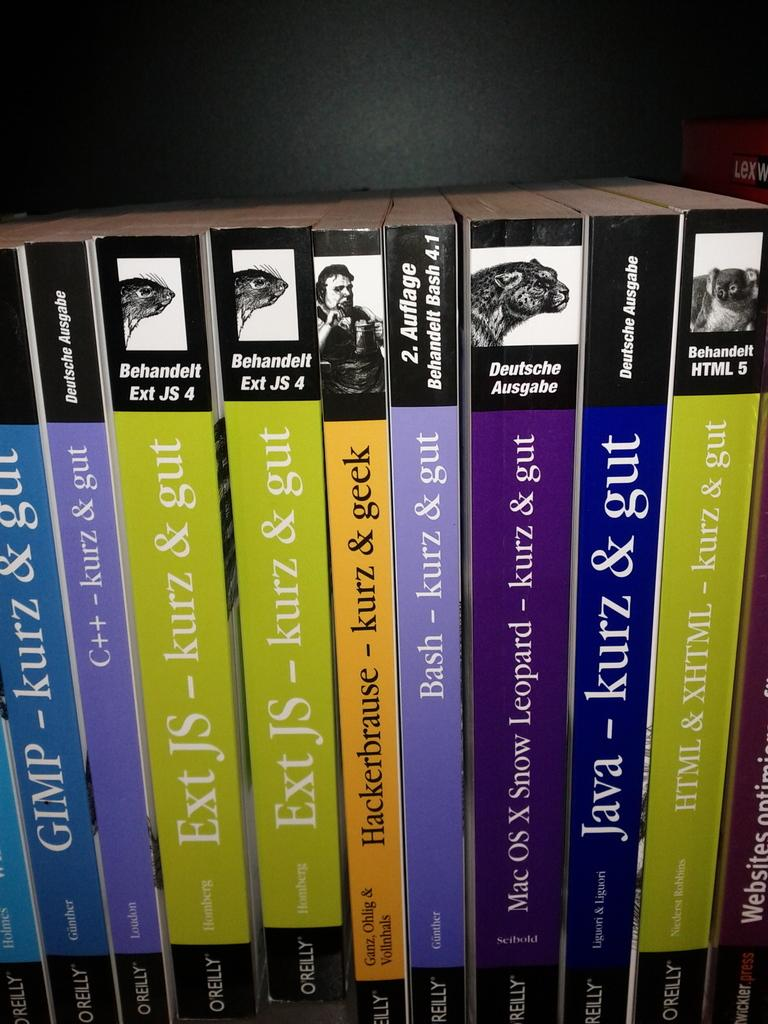<image>
Provide a brief description of the given image. a blue book with the word java on it 